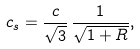<formula> <loc_0><loc_0><loc_500><loc_500>c _ { s } = \frac { c } { \sqrt { 3 } } \, \frac { 1 } { \sqrt { 1 + R } } ,</formula> 